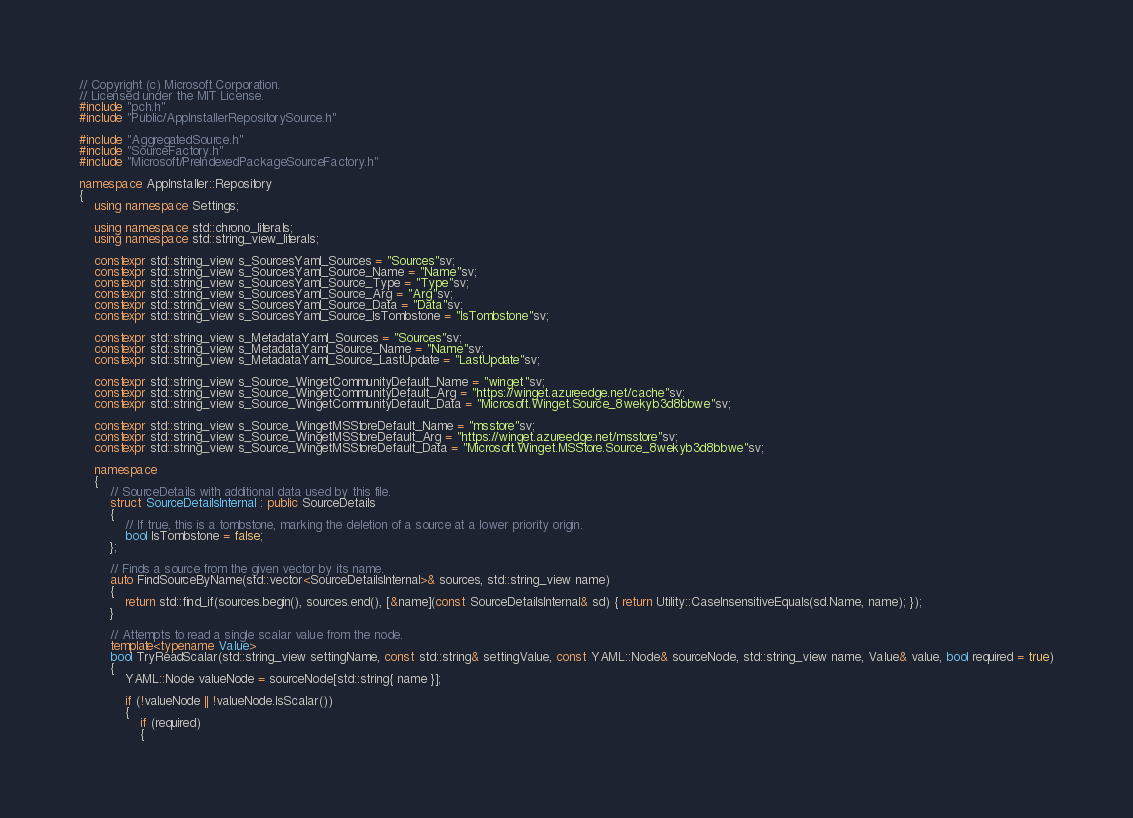Convert code to text. <code><loc_0><loc_0><loc_500><loc_500><_C++_>// Copyright (c) Microsoft Corporation.
// Licensed under the MIT License.
#include "pch.h"
#include "Public/AppInstallerRepositorySource.h"

#include "AggregatedSource.h"
#include "SourceFactory.h"
#include "Microsoft/PreIndexedPackageSourceFactory.h"

namespace AppInstaller::Repository
{
    using namespace Settings;

    using namespace std::chrono_literals;
    using namespace std::string_view_literals;

    constexpr std::string_view s_SourcesYaml_Sources = "Sources"sv;
    constexpr std::string_view s_SourcesYaml_Source_Name = "Name"sv;
    constexpr std::string_view s_SourcesYaml_Source_Type = "Type"sv;
    constexpr std::string_view s_SourcesYaml_Source_Arg = "Arg"sv;
    constexpr std::string_view s_SourcesYaml_Source_Data = "Data"sv;
    constexpr std::string_view s_SourcesYaml_Source_IsTombstone = "IsTombstone"sv;

    constexpr std::string_view s_MetadataYaml_Sources = "Sources"sv;
    constexpr std::string_view s_MetadataYaml_Source_Name = "Name"sv;
    constexpr std::string_view s_MetadataYaml_Source_LastUpdate = "LastUpdate"sv;

    constexpr std::string_view s_Source_WingetCommunityDefault_Name = "winget"sv;
    constexpr std::string_view s_Source_WingetCommunityDefault_Arg = "https://winget.azureedge.net/cache"sv;
    constexpr std::string_view s_Source_WingetCommunityDefault_Data = "Microsoft.Winget.Source_8wekyb3d8bbwe"sv;

    constexpr std::string_view s_Source_WingetMSStoreDefault_Name = "msstore"sv;
    constexpr std::string_view s_Source_WingetMSStoreDefault_Arg = "https://winget.azureedge.net/msstore"sv;
    constexpr std::string_view s_Source_WingetMSStoreDefault_Data = "Microsoft.Winget.MSStore.Source_8wekyb3d8bbwe"sv;

    namespace
    {
        // SourceDetails with additional data used by this file.
        struct SourceDetailsInternal : public SourceDetails
        {
            // If true, this is a tombstone, marking the deletion of a source at a lower priority origin.
            bool IsTombstone = false;
        };

        // Finds a source from the given vector by its name.
        auto FindSourceByName(std::vector<SourceDetailsInternal>& sources, std::string_view name)
        {
            return std::find_if(sources.begin(), sources.end(), [&name](const SourceDetailsInternal& sd) { return Utility::CaseInsensitiveEquals(sd.Name, name); });
        }

        // Attempts to read a single scalar value from the node.
        template<typename Value>
        bool TryReadScalar(std::string_view settingName, const std::string& settingValue, const YAML::Node& sourceNode, std::string_view name, Value& value, bool required = true)
        {
            YAML::Node valueNode = sourceNode[std::string{ name }];

            if (!valueNode || !valueNode.IsScalar())
            {
                if (required)
                {</code> 